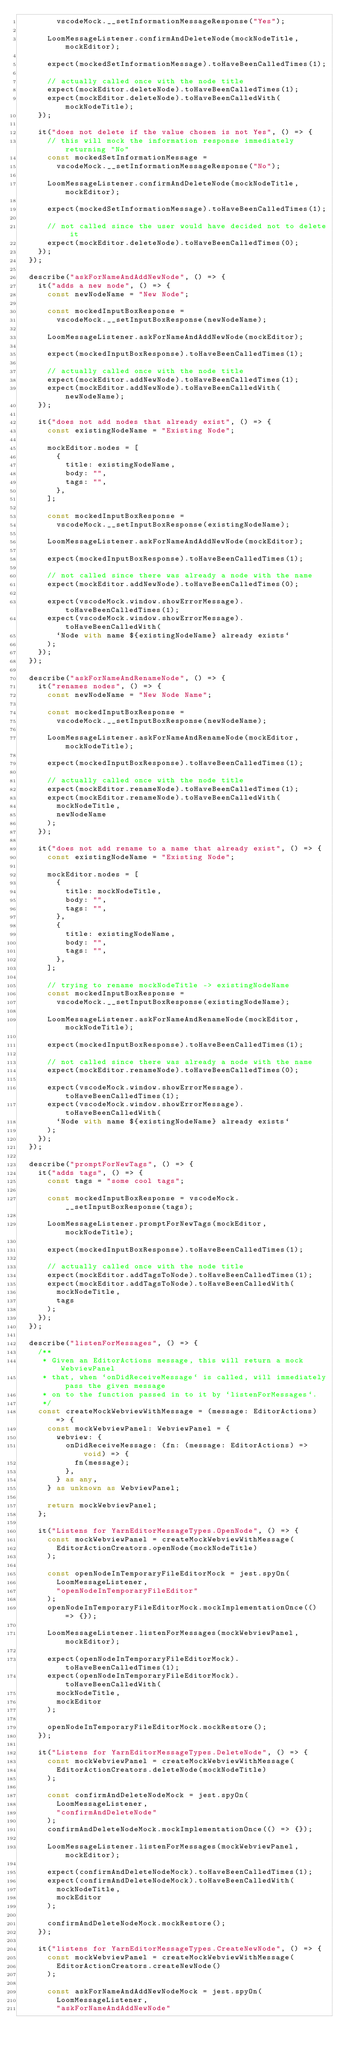Convert code to text. <code><loc_0><loc_0><loc_500><loc_500><_TypeScript_>        vscodeMock.__setInformationMessageResponse("Yes");

      LoomMessageListener.confirmAndDeleteNode(mockNodeTitle, mockEditor);

      expect(mockedSetInformationMessage).toHaveBeenCalledTimes(1);

      // actually called once with the node title
      expect(mockEditor.deleteNode).toHaveBeenCalledTimes(1);
      expect(mockEditor.deleteNode).toHaveBeenCalledWith(mockNodeTitle);
    });

    it("does not delete if the value chosen is not Yes", () => {
      // this will mock the information response immediately returning "No"
      const mockedSetInformationMessage =
        vscodeMock.__setInformationMessageResponse("No");

      LoomMessageListener.confirmAndDeleteNode(mockNodeTitle, mockEditor);

      expect(mockedSetInformationMessage).toHaveBeenCalledTimes(1);

      // not called since the user would have decided not to delete it
      expect(mockEditor.deleteNode).toHaveBeenCalledTimes(0);
    });
  });

  describe("askForNameAndAddNewNode", () => {
    it("adds a new node", () => {
      const newNodeName = "New Node";

      const mockedInputBoxResponse =
        vscodeMock.__setInputBoxResponse(newNodeName);

      LoomMessageListener.askForNameAndAddNewNode(mockEditor);

      expect(mockedInputBoxResponse).toHaveBeenCalledTimes(1);

      // actually called once with the node title
      expect(mockEditor.addNewNode).toHaveBeenCalledTimes(1);
      expect(mockEditor.addNewNode).toHaveBeenCalledWith(newNodeName);
    });

    it("does not add nodes that already exist", () => {
      const existingNodeName = "Existing Node";

      mockEditor.nodes = [
        {
          title: existingNodeName,
          body: "",
          tags: "",
        },
      ];

      const mockedInputBoxResponse =
        vscodeMock.__setInputBoxResponse(existingNodeName);

      LoomMessageListener.askForNameAndAddNewNode(mockEditor);

      expect(mockedInputBoxResponse).toHaveBeenCalledTimes(1);

      // not called since there was already a node with the name
      expect(mockEditor.addNewNode).toHaveBeenCalledTimes(0);

      expect(vscodeMock.window.showErrorMessage).toHaveBeenCalledTimes(1);
      expect(vscodeMock.window.showErrorMessage).toHaveBeenCalledWith(
        `Node with name ${existingNodeName} already exists`
      );
    });
  });

  describe("askForNameAndRenameNode", () => {
    it("renames nodes", () => {
      const newNodeName = "New Node Name";

      const mockedInputBoxResponse =
        vscodeMock.__setInputBoxResponse(newNodeName);

      LoomMessageListener.askForNameAndRenameNode(mockEditor, mockNodeTitle);

      expect(mockedInputBoxResponse).toHaveBeenCalledTimes(1);

      // actually called once with the node title
      expect(mockEditor.renameNode).toHaveBeenCalledTimes(1);
      expect(mockEditor.renameNode).toHaveBeenCalledWith(
        mockNodeTitle,
        newNodeName
      );
    });

    it("does not add rename to a name that already exist", () => {
      const existingNodeName = "Existing Node";

      mockEditor.nodes = [
        {
          title: mockNodeTitle,
          body: "",
          tags: "",
        },
        {
          title: existingNodeName,
          body: "",
          tags: "",
        },
      ];

      // trying to rename mockNodeTitle -> existingNodeName
      const mockedInputBoxResponse =
        vscodeMock.__setInputBoxResponse(existingNodeName);

      LoomMessageListener.askForNameAndRenameNode(mockEditor, mockNodeTitle);

      expect(mockedInputBoxResponse).toHaveBeenCalledTimes(1);

      // not called since there was already a node with the name
      expect(mockEditor.renameNode).toHaveBeenCalledTimes(0);

      expect(vscodeMock.window.showErrorMessage).toHaveBeenCalledTimes(1);
      expect(vscodeMock.window.showErrorMessage).toHaveBeenCalledWith(
        `Node with name ${existingNodeName} already exists`
      );
    });
  });

  describe("promptForNewTags", () => {
    it("adds tags", () => {
      const tags = "some cool tags";

      const mockedInputBoxResponse = vscodeMock.__setInputBoxResponse(tags);

      LoomMessageListener.promptForNewTags(mockEditor, mockNodeTitle);

      expect(mockedInputBoxResponse).toHaveBeenCalledTimes(1);

      // actually called once with the node title
      expect(mockEditor.addTagsToNode).toHaveBeenCalledTimes(1);
      expect(mockEditor.addTagsToNode).toHaveBeenCalledWith(
        mockNodeTitle,
        tags
      );
    });
  });

  describe("listenForMessages", () => {
    /**
     * Given an EditorActions message, this will return a mock WebviewPanel
     * that, when `onDidReceiveMessage` is called, will immediately pass the given message
     * on to the function passed in to it by `listenForMessages`.
     */
    const createMockWebviewWithMessage = (message: EditorActions) => {
      const mockWebviewPanel: WebviewPanel = {
        webview: {
          onDidReceiveMessage: (fn: (message: EditorActions) => void) => {
            fn(message);
          },
        } as any,
      } as unknown as WebviewPanel;

      return mockWebviewPanel;
    };

    it("Listens for YarnEditorMessageTypes.OpenNode", () => {
      const mockWebviewPanel = createMockWebviewWithMessage(
        EditorActionCreators.openNode(mockNodeTitle)
      );

      const openNodeInTemporaryFileEditorMock = jest.spyOn(
        LoomMessageListener,
        "openNodeInTemporaryFileEditor"
      );
      openNodeInTemporaryFileEditorMock.mockImplementationOnce(() => {});

      LoomMessageListener.listenForMessages(mockWebviewPanel, mockEditor);

      expect(openNodeInTemporaryFileEditorMock).toHaveBeenCalledTimes(1);
      expect(openNodeInTemporaryFileEditorMock).toHaveBeenCalledWith(
        mockNodeTitle,
        mockEditor
      );

      openNodeInTemporaryFileEditorMock.mockRestore();
    });

    it("Listens for YarnEditorMessageTypes.DeleteNode", () => {
      const mockWebviewPanel = createMockWebviewWithMessage(
        EditorActionCreators.deleteNode(mockNodeTitle)
      );

      const confirmAndDeleteNodeMock = jest.spyOn(
        LoomMessageListener,
        "confirmAndDeleteNode"
      );
      confirmAndDeleteNodeMock.mockImplementationOnce(() => {});

      LoomMessageListener.listenForMessages(mockWebviewPanel, mockEditor);

      expect(confirmAndDeleteNodeMock).toHaveBeenCalledTimes(1);
      expect(confirmAndDeleteNodeMock).toHaveBeenCalledWith(
        mockNodeTitle,
        mockEditor
      );

      confirmAndDeleteNodeMock.mockRestore();
    });

    it("listens for YarnEditorMessageTypes.CreateNewNode", () => {
      const mockWebviewPanel = createMockWebviewWithMessage(
        EditorActionCreators.createNewNode()
      );

      const askForNameAndAddNewNodeMock = jest.spyOn(
        LoomMessageListener,
        "askForNameAndAddNewNode"</code> 